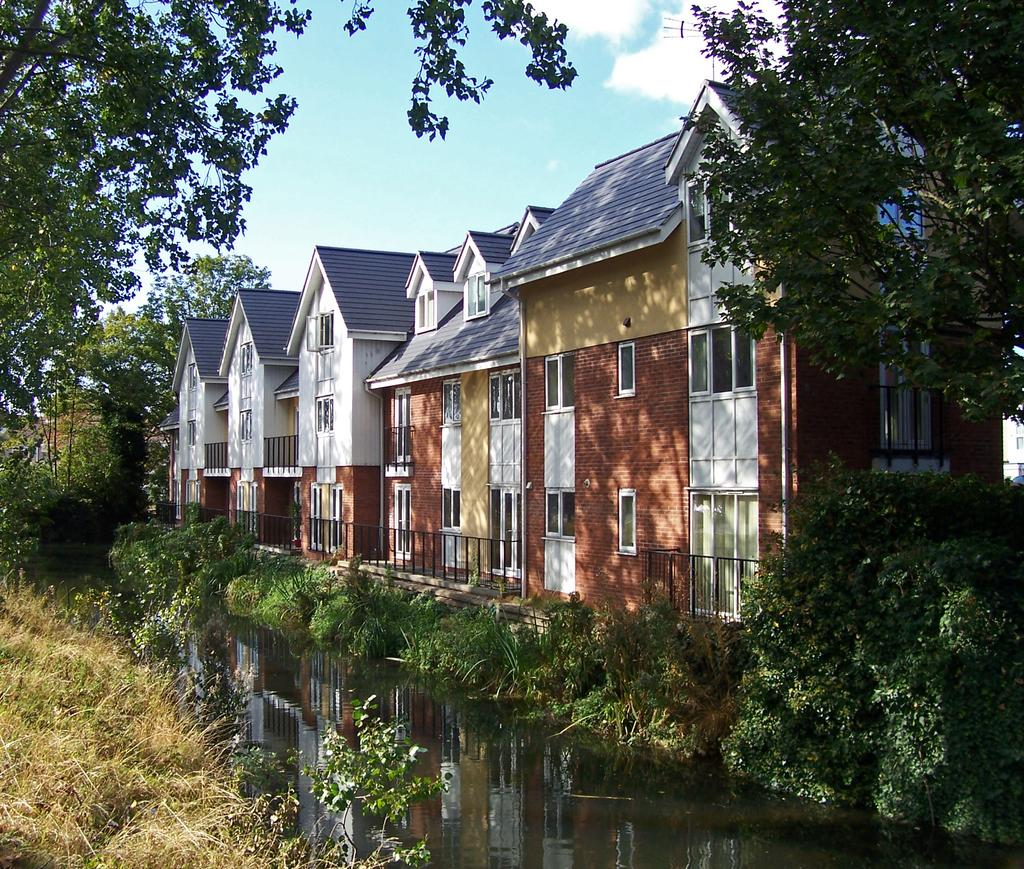What type of living organisms can be seen in the image? Plants and trees are visible in the image. What natural element is present in the image? There is water visible in the image. What type of structures can be seen in the image? There are buildings in the image. What can be seen in the background of the image? There are clouds in the background of the image. What type of cheese is being served at the committee meeting in the image? There is no committee meeting or cheese present in the image. 